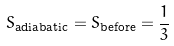Convert formula to latex. <formula><loc_0><loc_0><loc_500><loc_500>S _ { \text {adiabatic} } = S _ { \text {before} } = \frac { 1 } { 3 }</formula> 